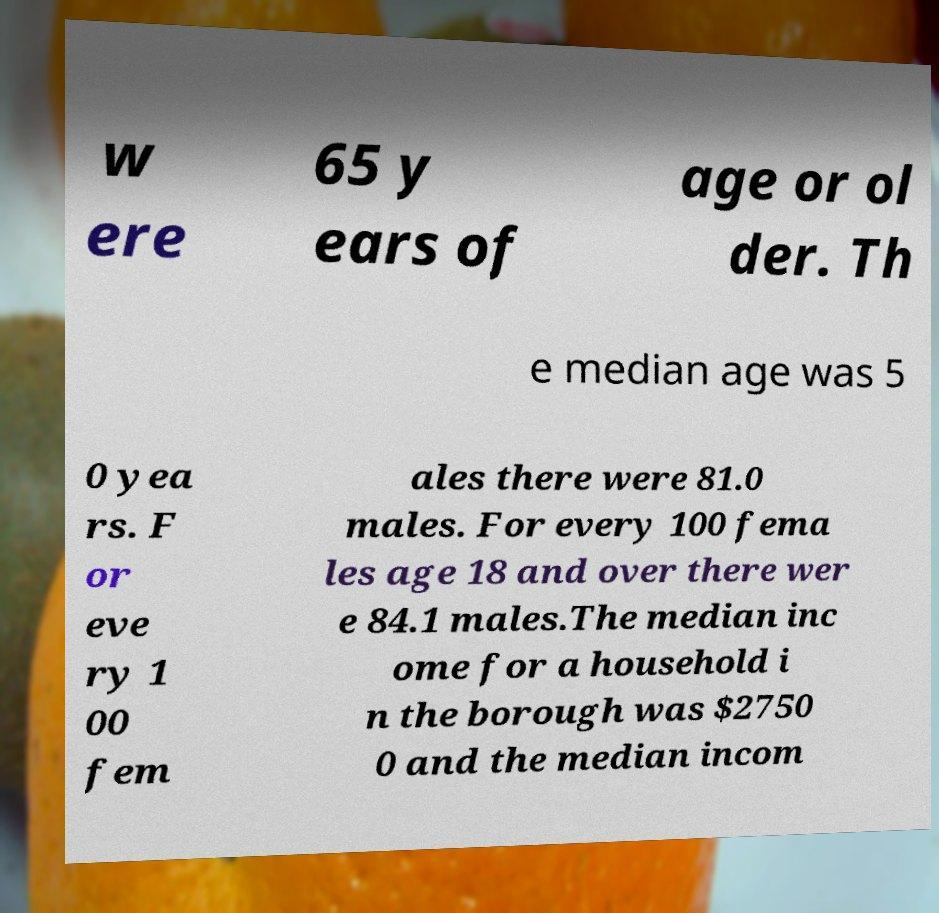Can you read and provide the text displayed in the image?This photo seems to have some interesting text. Can you extract and type it out for me? w ere 65 y ears of age or ol der. Th e median age was 5 0 yea rs. F or eve ry 1 00 fem ales there were 81.0 males. For every 100 fema les age 18 and over there wer e 84.1 males.The median inc ome for a household i n the borough was $2750 0 and the median incom 